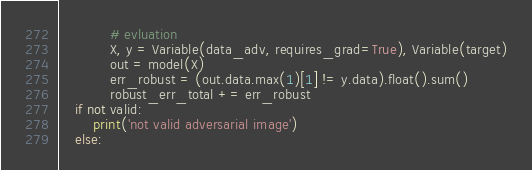Convert code to text. <code><loc_0><loc_0><loc_500><loc_500><_Python_>
            # evluation
            X, y = Variable(data_adv, requires_grad=True), Variable(target)
            out = model(X)
            err_robust = (out.data.max(1)[1] != y.data).float().sum()
            robust_err_total += err_robust
    if not valid:
        print('not valid adversarial image')
    else:</code> 